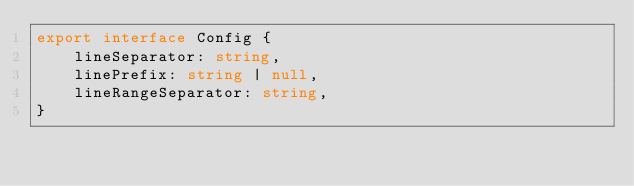Convert code to text. <code><loc_0><loc_0><loc_500><loc_500><_TypeScript_>export interface Config {
    lineSeparator: string,
    linePrefix: string | null,
    lineRangeSeparator: string,
}
</code> 